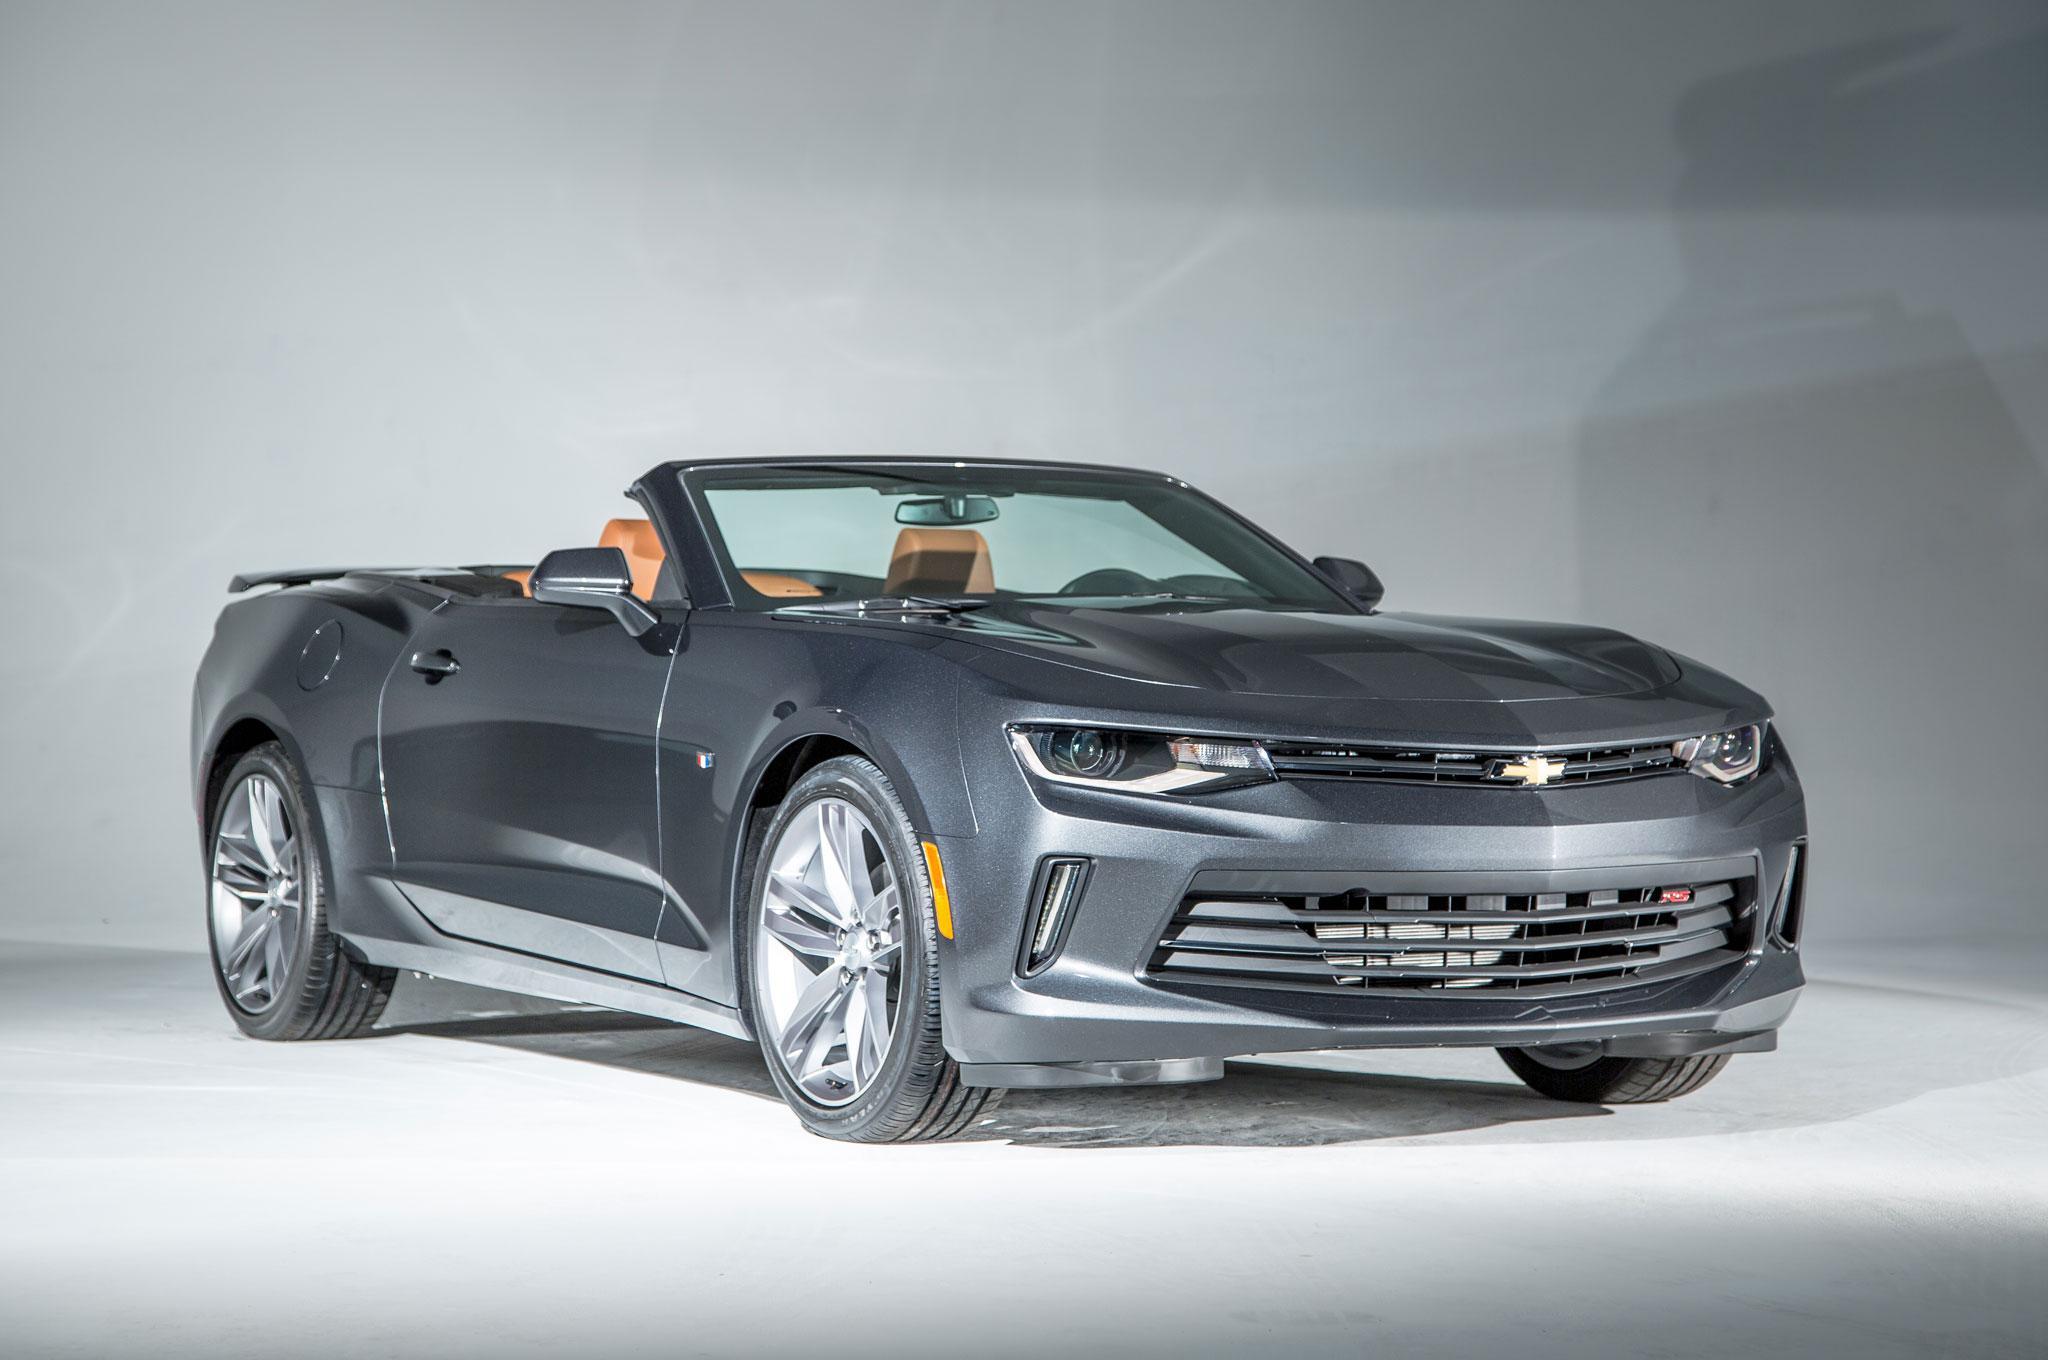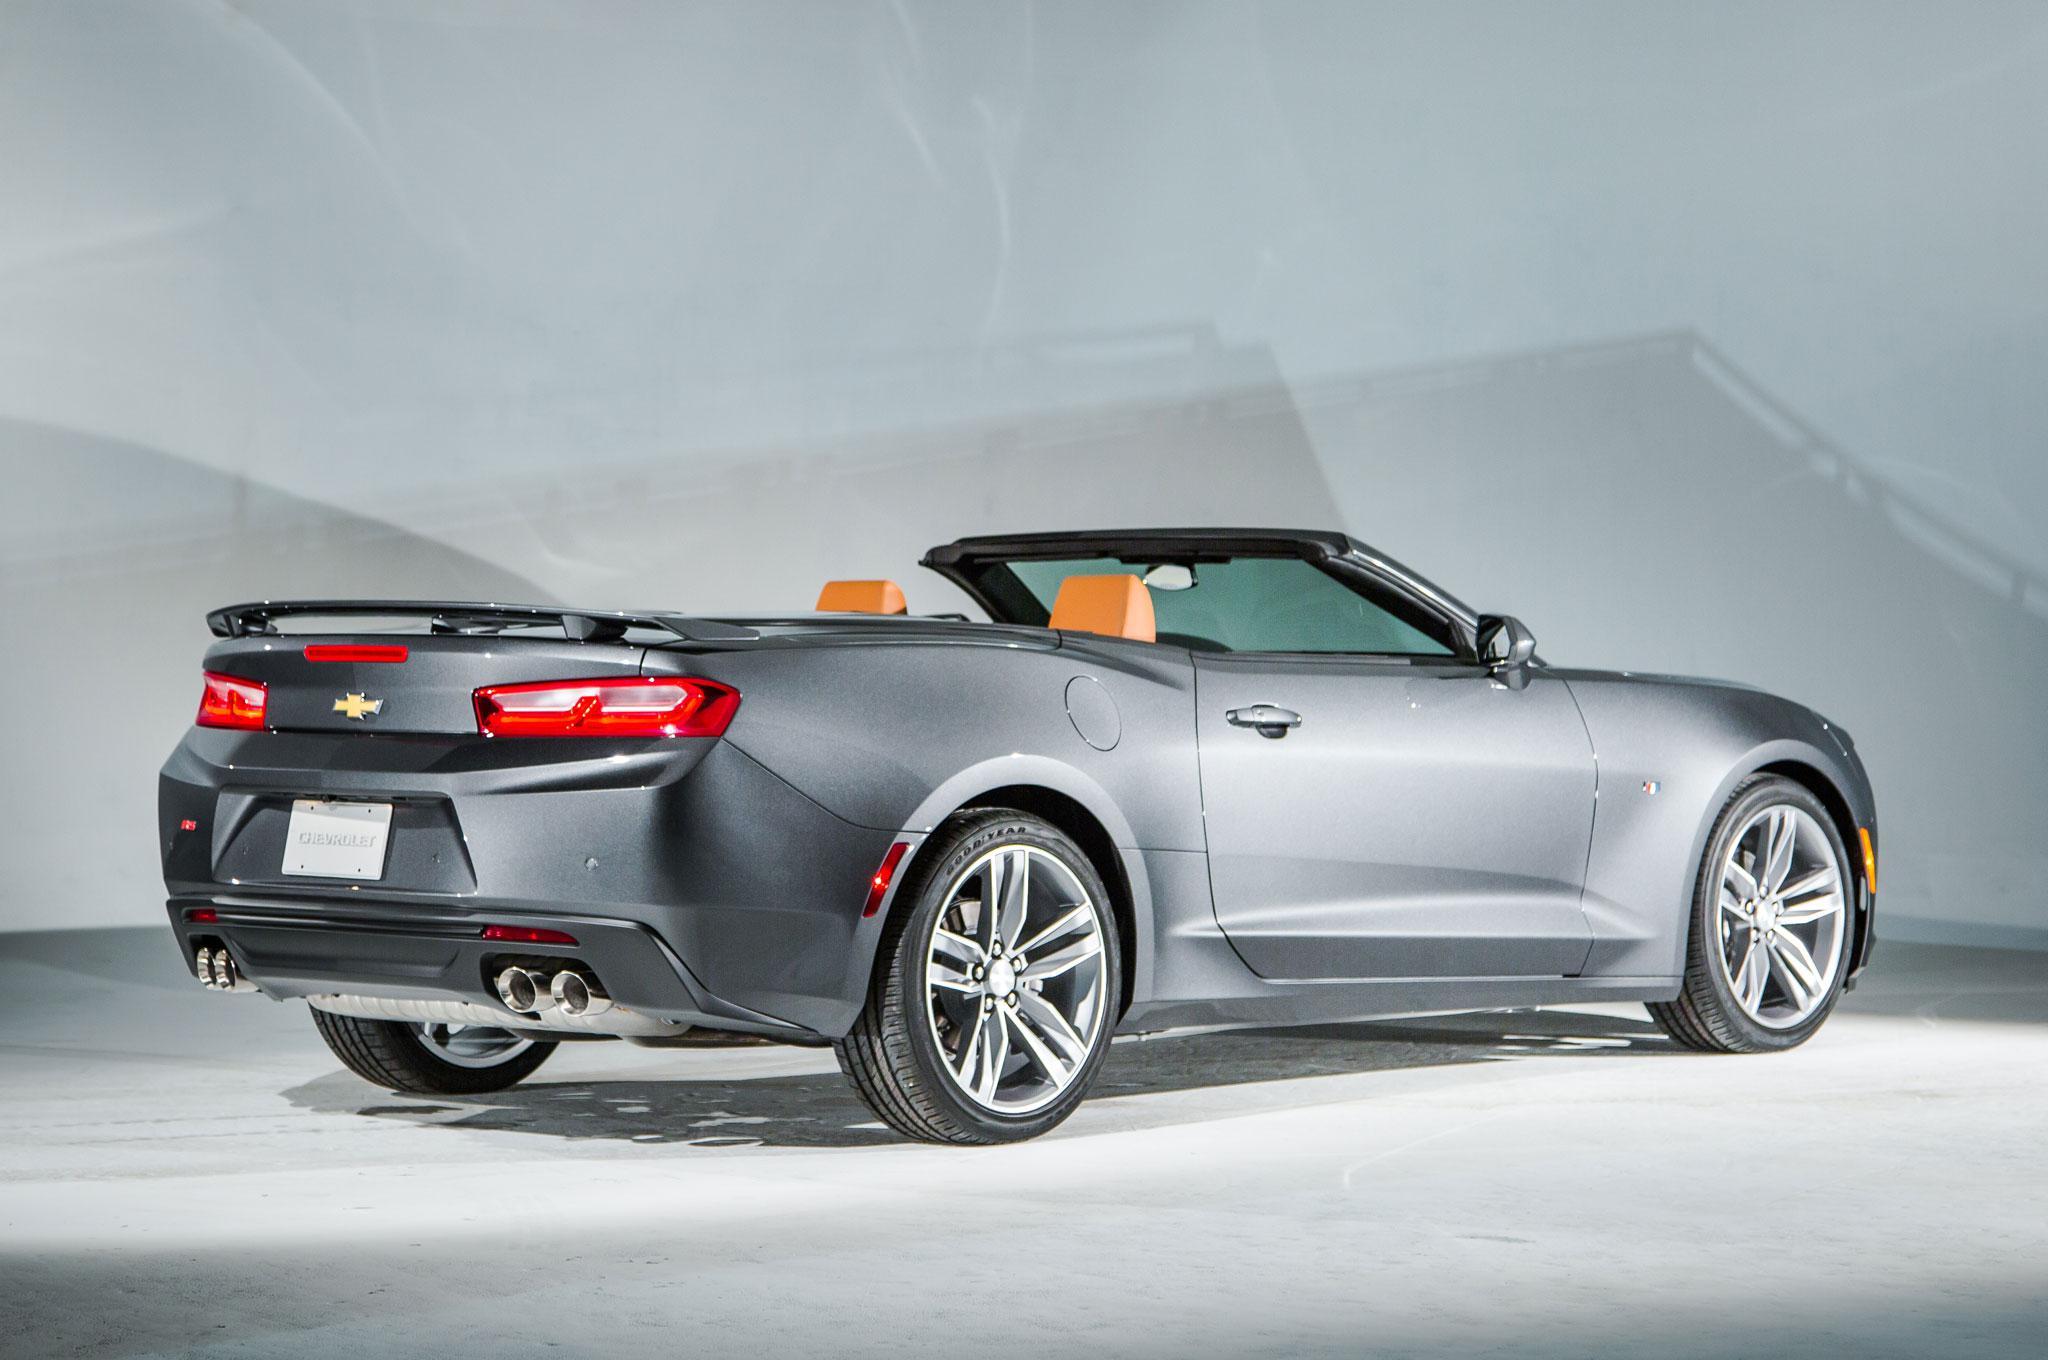The first image is the image on the left, the second image is the image on the right. Assess this claim about the two images: "The cars in both images are parked indoors.". Correct or not? Answer yes or no. Yes. The first image is the image on the left, the second image is the image on the right. Evaluate the accuracy of this statement regarding the images: "An image shows an angled white convertible with top down in an outdoor scene.". Is it true? Answer yes or no. No. 